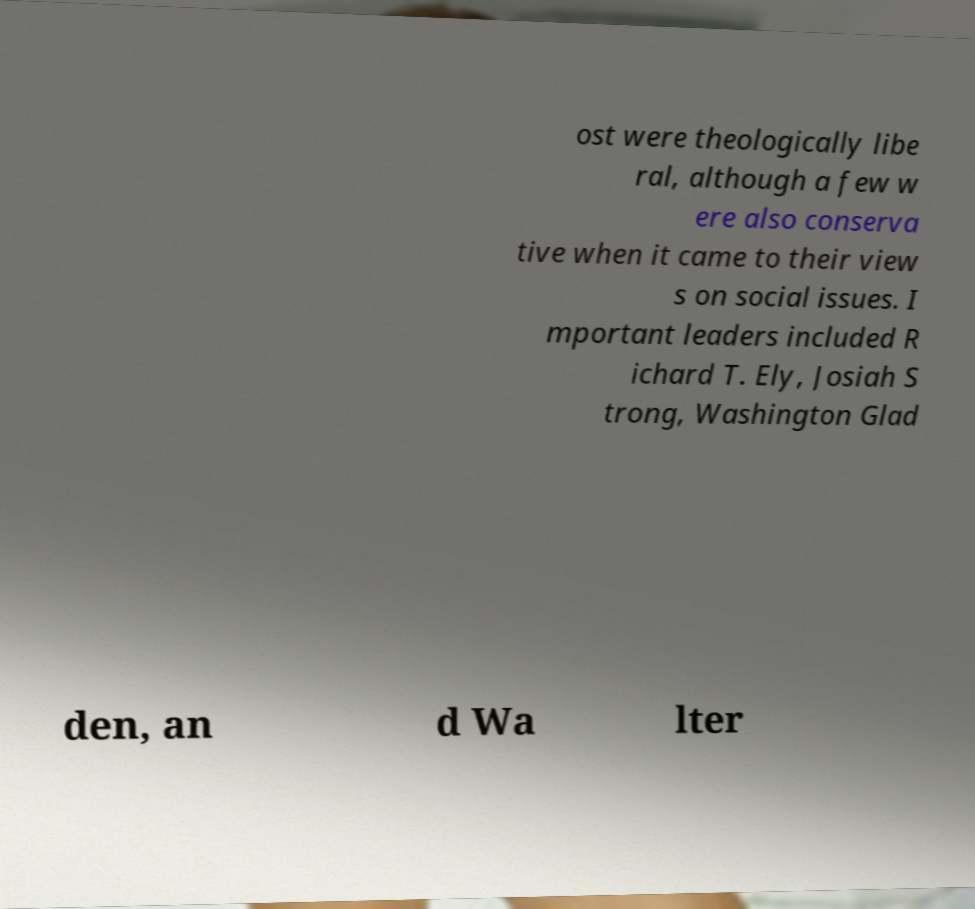Please read and relay the text visible in this image. What does it say? ost were theologically libe ral, although a few w ere also conserva tive when it came to their view s on social issues. I mportant leaders included R ichard T. Ely, Josiah S trong, Washington Glad den, an d Wa lter 